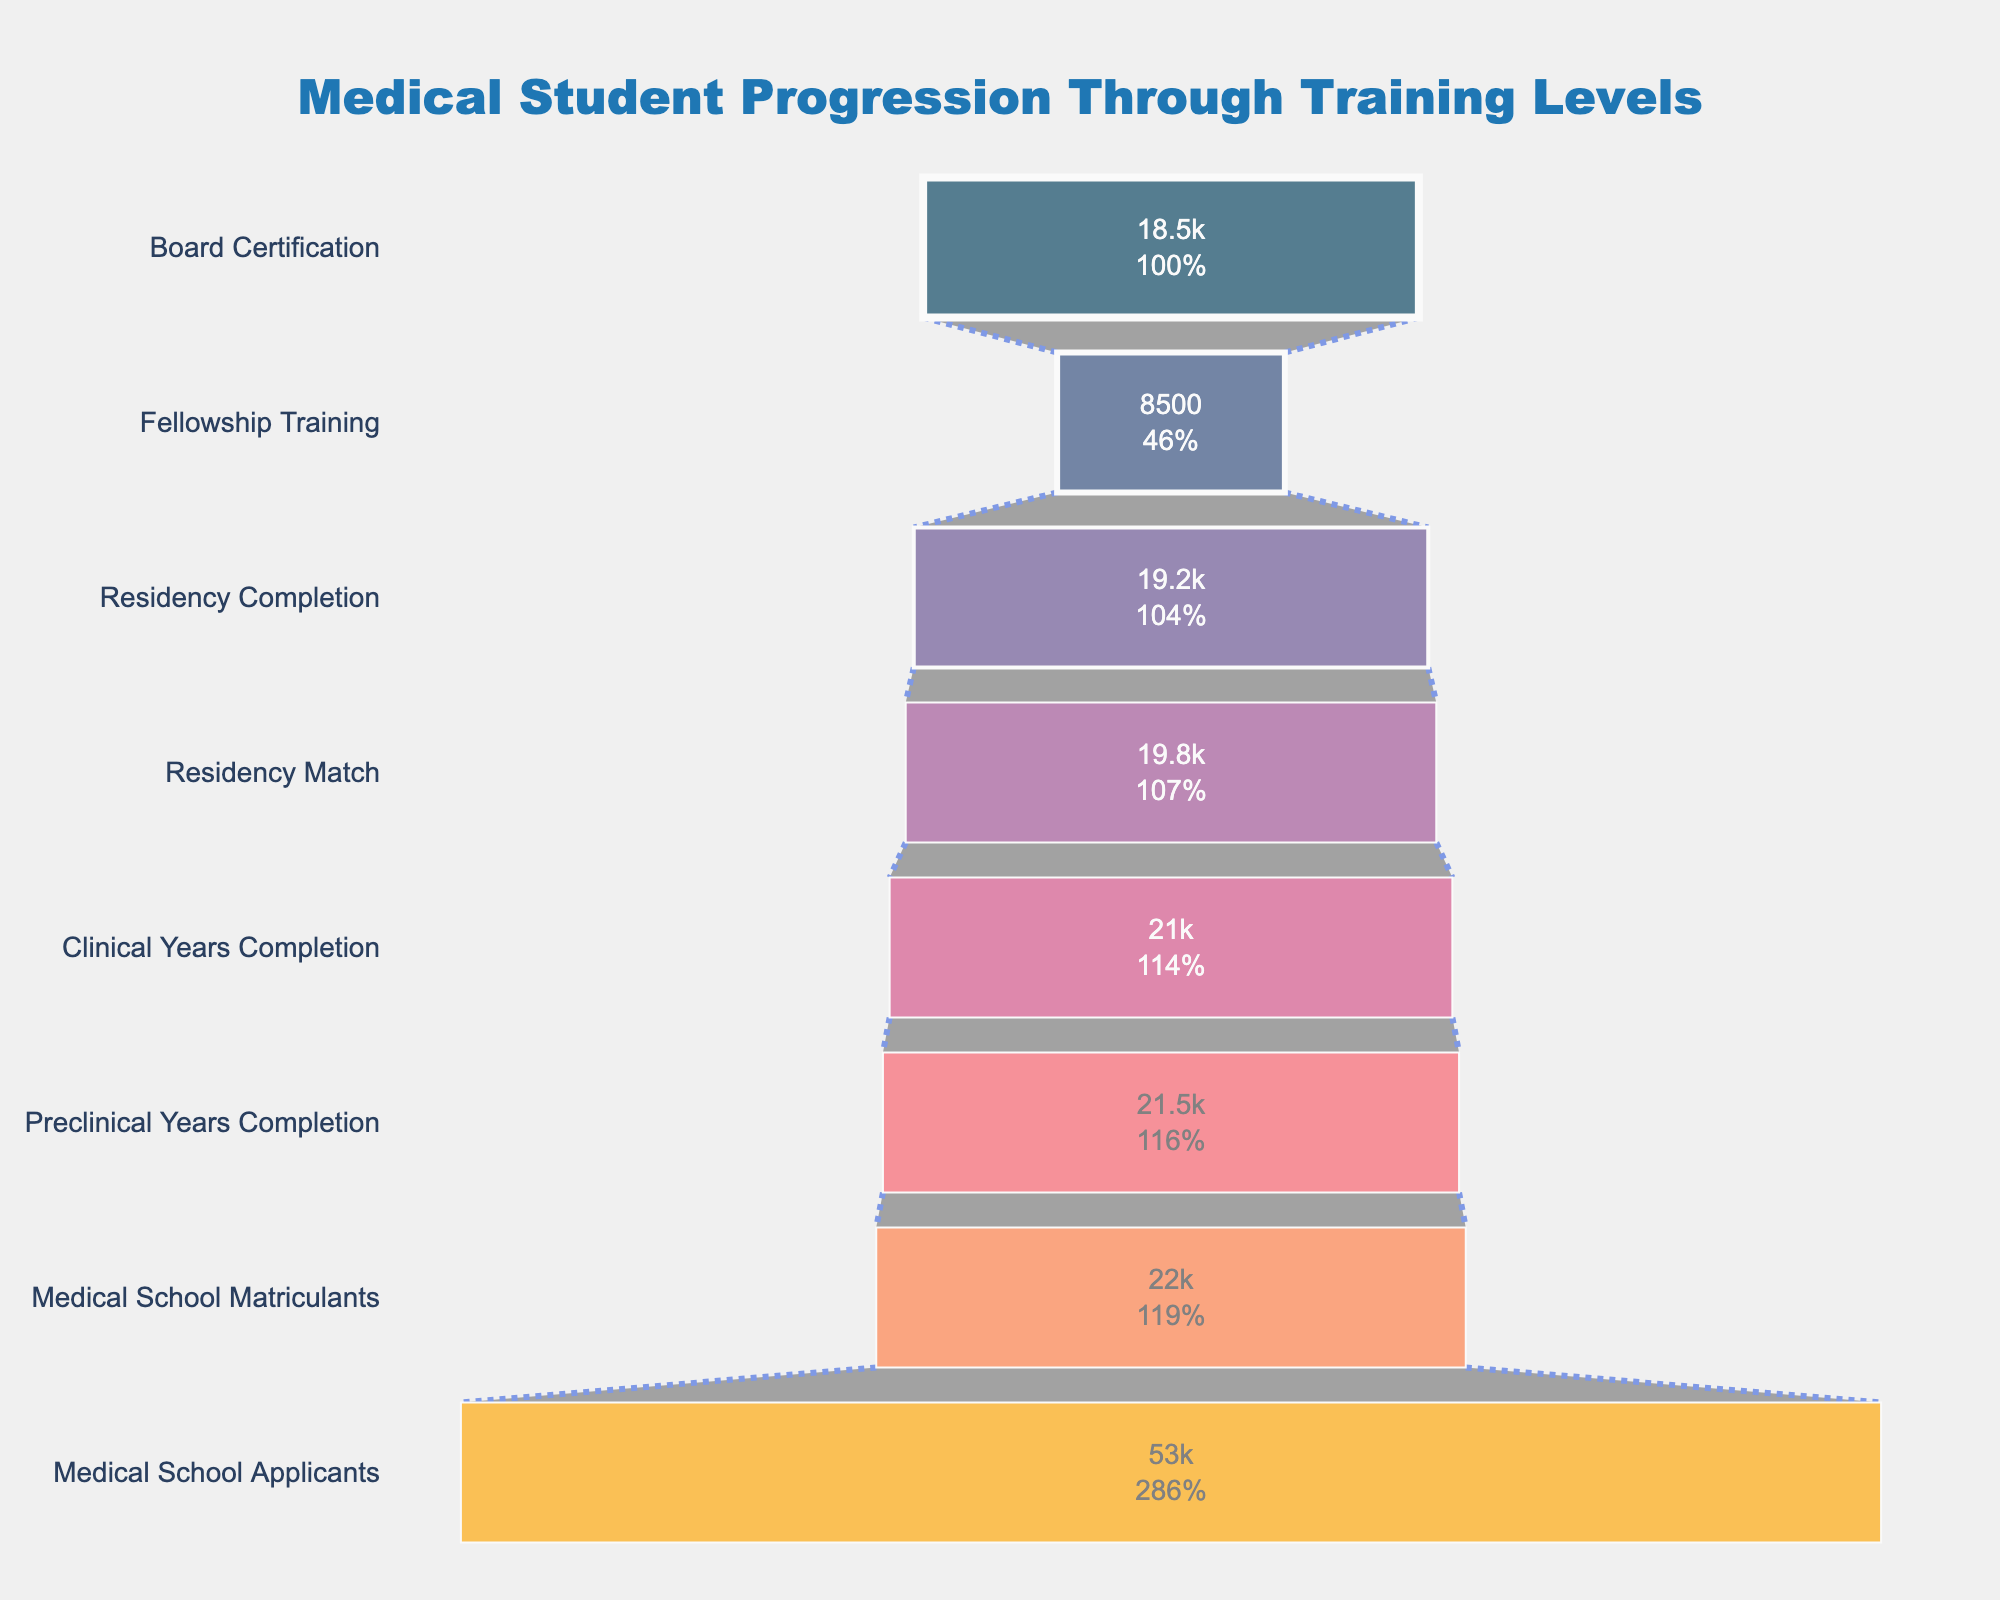What is the title of the figure? The title can be found at the top of the figure. It is designed to provide an overview of what the chart represents.
Answer: Medical Student Progression Through Training Levels What is the initial number of medical school applicants? This refers to the first stage from the top of the funnel, where the number of students is indicated inside the bar.
Answer: 53000 What stage follows 'Clinical Years Completion'? By reading the progression stages from the top down, you can see which stage comes immediately after 'Clinical Years Completion'.
Answer: Residency Match How many students complete the preclinical years? Look for 'Preclinical Years Completion' in the funnel. The number of students at this stage is written inside the corresponding segment.
Answer: 21500 